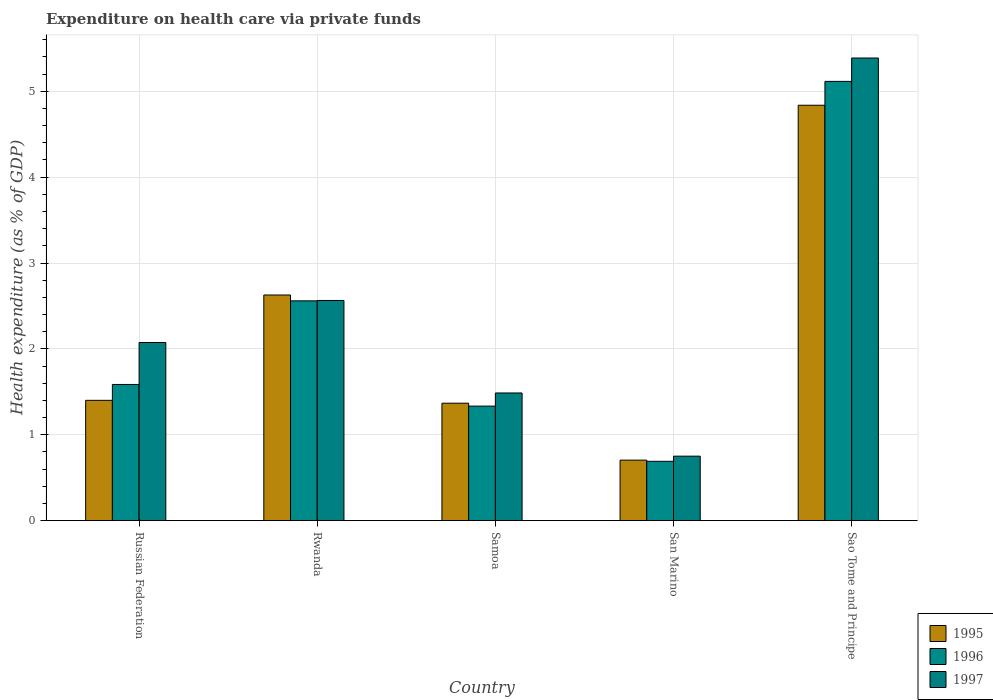How many bars are there on the 5th tick from the left?
Give a very brief answer. 3. What is the label of the 2nd group of bars from the left?
Offer a very short reply. Rwanda. In how many cases, is the number of bars for a given country not equal to the number of legend labels?
Your answer should be compact. 0. What is the expenditure made on health care in 1997 in Russian Federation?
Give a very brief answer. 2.07. Across all countries, what is the maximum expenditure made on health care in 1997?
Make the answer very short. 5.39. Across all countries, what is the minimum expenditure made on health care in 1996?
Offer a very short reply. 0.69. In which country was the expenditure made on health care in 1996 maximum?
Ensure brevity in your answer.  Sao Tome and Principe. In which country was the expenditure made on health care in 1996 minimum?
Ensure brevity in your answer.  San Marino. What is the total expenditure made on health care in 1995 in the graph?
Your response must be concise. 10.94. What is the difference between the expenditure made on health care in 1997 in Rwanda and that in San Marino?
Ensure brevity in your answer.  1.81. What is the difference between the expenditure made on health care in 1997 in Samoa and the expenditure made on health care in 1996 in San Marino?
Give a very brief answer. 0.8. What is the average expenditure made on health care in 1996 per country?
Your answer should be very brief. 2.26. What is the difference between the expenditure made on health care of/in 1995 and expenditure made on health care of/in 1996 in San Marino?
Ensure brevity in your answer.  0.01. In how many countries, is the expenditure made on health care in 1996 greater than 3 %?
Make the answer very short. 1. What is the ratio of the expenditure made on health care in 1996 in Rwanda to that in Samoa?
Provide a short and direct response. 1.92. Is the difference between the expenditure made on health care in 1995 in Russian Federation and Rwanda greater than the difference between the expenditure made on health care in 1996 in Russian Federation and Rwanda?
Offer a terse response. No. What is the difference between the highest and the second highest expenditure made on health care in 1997?
Give a very brief answer. 0.49. What is the difference between the highest and the lowest expenditure made on health care in 1997?
Provide a succinct answer. 4.64. In how many countries, is the expenditure made on health care in 1997 greater than the average expenditure made on health care in 1997 taken over all countries?
Make the answer very short. 2. Is the sum of the expenditure made on health care in 1995 in Rwanda and Sao Tome and Principe greater than the maximum expenditure made on health care in 1996 across all countries?
Keep it short and to the point. Yes. What does the 1st bar from the left in San Marino represents?
Provide a short and direct response. 1995. What does the 1st bar from the right in Sao Tome and Principe represents?
Offer a terse response. 1997. Is it the case that in every country, the sum of the expenditure made on health care in 1995 and expenditure made on health care in 1996 is greater than the expenditure made on health care in 1997?
Your response must be concise. Yes. What is the difference between two consecutive major ticks on the Y-axis?
Make the answer very short. 1. Are the values on the major ticks of Y-axis written in scientific E-notation?
Your answer should be compact. No. Does the graph contain grids?
Provide a short and direct response. Yes. How are the legend labels stacked?
Your response must be concise. Vertical. What is the title of the graph?
Offer a terse response. Expenditure on health care via private funds. What is the label or title of the Y-axis?
Make the answer very short. Health expenditure (as % of GDP). What is the Health expenditure (as % of GDP) in 1995 in Russian Federation?
Provide a succinct answer. 1.4. What is the Health expenditure (as % of GDP) in 1996 in Russian Federation?
Provide a short and direct response. 1.59. What is the Health expenditure (as % of GDP) of 1997 in Russian Federation?
Give a very brief answer. 2.07. What is the Health expenditure (as % of GDP) of 1995 in Rwanda?
Give a very brief answer. 2.63. What is the Health expenditure (as % of GDP) of 1996 in Rwanda?
Keep it short and to the point. 2.56. What is the Health expenditure (as % of GDP) of 1997 in Rwanda?
Keep it short and to the point. 2.56. What is the Health expenditure (as % of GDP) in 1995 in Samoa?
Offer a very short reply. 1.37. What is the Health expenditure (as % of GDP) in 1996 in Samoa?
Your answer should be compact. 1.33. What is the Health expenditure (as % of GDP) of 1997 in Samoa?
Provide a short and direct response. 1.49. What is the Health expenditure (as % of GDP) of 1995 in San Marino?
Give a very brief answer. 0.7. What is the Health expenditure (as % of GDP) of 1996 in San Marino?
Your answer should be compact. 0.69. What is the Health expenditure (as % of GDP) in 1997 in San Marino?
Offer a terse response. 0.75. What is the Health expenditure (as % of GDP) of 1995 in Sao Tome and Principe?
Your response must be concise. 4.84. What is the Health expenditure (as % of GDP) in 1996 in Sao Tome and Principe?
Make the answer very short. 5.12. What is the Health expenditure (as % of GDP) of 1997 in Sao Tome and Principe?
Ensure brevity in your answer.  5.39. Across all countries, what is the maximum Health expenditure (as % of GDP) in 1995?
Provide a short and direct response. 4.84. Across all countries, what is the maximum Health expenditure (as % of GDP) of 1996?
Offer a very short reply. 5.12. Across all countries, what is the maximum Health expenditure (as % of GDP) of 1997?
Your answer should be compact. 5.39. Across all countries, what is the minimum Health expenditure (as % of GDP) of 1995?
Offer a very short reply. 0.7. Across all countries, what is the minimum Health expenditure (as % of GDP) of 1996?
Make the answer very short. 0.69. Across all countries, what is the minimum Health expenditure (as % of GDP) in 1997?
Offer a terse response. 0.75. What is the total Health expenditure (as % of GDP) of 1995 in the graph?
Give a very brief answer. 10.94. What is the total Health expenditure (as % of GDP) in 1996 in the graph?
Your answer should be compact. 11.28. What is the total Health expenditure (as % of GDP) in 1997 in the graph?
Provide a succinct answer. 12.26. What is the difference between the Health expenditure (as % of GDP) of 1995 in Russian Federation and that in Rwanda?
Offer a very short reply. -1.23. What is the difference between the Health expenditure (as % of GDP) of 1996 in Russian Federation and that in Rwanda?
Keep it short and to the point. -0.97. What is the difference between the Health expenditure (as % of GDP) in 1997 in Russian Federation and that in Rwanda?
Give a very brief answer. -0.49. What is the difference between the Health expenditure (as % of GDP) of 1996 in Russian Federation and that in Samoa?
Your response must be concise. 0.25. What is the difference between the Health expenditure (as % of GDP) of 1997 in Russian Federation and that in Samoa?
Give a very brief answer. 0.59. What is the difference between the Health expenditure (as % of GDP) of 1995 in Russian Federation and that in San Marino?
Your answer should be very brief. 0.7. What is the difference between the Health expenditure (as % of GDP) in 1996 in Russian Federation and that in San Marino?
Your answer should be very brief. 0.9. What is the difference between the Health expenditure (as % of GDP) of 1997 in Russian Federation and that in San Marino?
Your response must be concise. 1.32. What is the difference between the Health expenditure (as % of GDP) in 1995 in Russian Federation and that in Sao Tome and Principe?
Give a very brief answer. -3.44. What is the difference between the Health expenditure (as % of GDP) in 1996 in Russian Federation and that in Sao Tome and Principe?
Provide a succinct answer. -3.53. What is the difference between the Health expenditure (as % of GDP) in 1997 in Russian Federation and that in Sao Tome and Principe?
Make the answer very short. -3.31. What is the difference between the Health expenditure (as % of GDP) of 1995 in Rwanda and that in Samoa?
Keep it short and to the point. 1.26. What is the difference between the Health expenditure (as % of GDP) of 1996 in Rwanda and that in Samoa?
Ensure brevity in your answer.  1.23. What is the difference between the Health expenditure (as % of GDP) of 1997 in Rwanda and that in Samoa?
Offer a very short reply. 1.08. What is the difference between the Health expenditure (as % of GDP) of 1995 in Rwanda and that in San Marino?
Keep it short and to the point. 1.92. What is the difference between the Health expenditure (as % of GDP) in 1996 in Rwanda and that in San Marino?
Provide a short and direct response. 1.87. What is the difference between the Health expenditure (as % of GDP) of 1997 in Rwanda and that in San Marino?
Your response must be concise. 1.81. What is the difference between the Health expenditure (as % of GDP) in 1995 in Rwanda and that in Sao Tome and Principe?
Your response must be concise. -2.21. What is the difference between the Health expenditure (as % of GDP) in 1996 in Rwanda and that in Sao Tome and Principe?
Ensure brevity in your answer.  -2.56. What is the difference between the Health expenditure (as % of GDP) in 1997 in Rwanda and that in Sao Tome and Principe?
Provide a short and direct response. -2.82. What is the difference between the Health expenditure (as % of GDP) in 1995 in Samoa and that in San Marino?
Ensure brevity in your answer.  0.66. What is the difference between the Health expenditure (as % of GDP) of 1996 in Samoa and that in San Marino?
Give a very brief answer. 0.64. What is the difference between the Health expenditure (as % of GDP) in 1997 in Samoa and that in San Marino?
Offer a very short reply. 0.74. What is the difference between the Health expenditure (as % of GDP) of 1995 in Samoa and that in Sao Tome and Principe?
Make the answer very short. -3.47. What is the difference between the Health expenditure (as % of GDP) of 1996 in Samoa and that in Sao Tome and Principe?
Give a very brief answer. -3.78. What is the difference between the Health expenditure (as % of GDP) in 1997 in Samoa and that in Sao Tome and Principe?
Your response must be concise. -3.9. What is the difference between the Health expenditure (as % of GDP) of 1995 in San Marino and that in Sao Tome and Principe?
Give a very brief answer. -4.13. What is the difference between the Health expenditure (as % of GDP) in 1996 in San Marino and that in Sao Tome and Principe?
Your answer should be very brief. -4.43. What is the difference between the Health expenditure (as % of GDP) of 1997 in San Marino and that in Sao Tome and Principe?
Keep it short and to the point. -4.64. What is the difference between the Health expenditure (as % of GDP) of 1995 in Russian Federation and the Health expenditure (as % of GDP) of 1996 in Rwanda?
Provide a succinct answer. -1.16. What is the difference between the Health expenditure (as % of GDP) in 1995 in Russian Federation and the Health expenditure (as % of GDP) in 1997 in Rwanda?
Provide a short and direct response. -1.16. What is the difference between the Health expenditure (as % of GDP) in 1996 in Russian Federation and the Health expenditure (as % of GDP) in 1997 in Rwanda?
Keep it short and to the point. -0.98. What is the difference between the Health expenditure (as % of GDP) in 1995 in Russian Federation and the Health expenditure (as % of GDP) in 1996 in Samoa?
Make the answer very short. 0.07. What is the difference between the Health expenditure (as % of GDP) in 1995 in Russian Federation and the Health expenditure (as % of GDP) in 1997 in Samoa?
Ensure brevity in your answer.  -0.09. What is the difference between the Health expenditure (as % of GDP) of 1996 in Russian Federation and the Health expenditure (as % of GDP) of 1997 in Samoa?
Make the answer very short. 0.1. What is the difference between the Health expenditure (as % of GDP) of 1995 in Russian Federation and the Health expenditure (as % of GDP) of 1996 in San Marino?
Your answer should be compact. 0.71. What is the difference between the Health expenditure (as % of GDP) in 1995 in Russian Federation and the Health expenditure (as % of GDP) in 1997 in San Marino?
Make the answer very short. 0.65. What is the difference between the Health expenditure (as % of GDP) of 1996 in Russian Federation and the Health expenditure (as % of GDP) of 1997 in San Marino?
Your response must be concise. 0.84. What is the difference between the Health expenditure (as % of GDP) of 1995 in Russian Federation and the Health expenditure (as % of GDP) of 1996 in Sao Tome and Principe?
Give a very brief answer. -3.72. What is the difference between the Health expenditure (as % of GDP) of 1995 in Russian Federation and the Health expenditure (as % of GDP) of 1997 in Sao Tome and Principe?
Make the answer very short. -3.99. What is the difference between the Health expenditure (as % of GDP) in 1996 in Russian Federation and the Health expenditure (as % of GDP) in 1997 in Sao Tome and Principe?
Provide a succinct answer. -3.8. What is the difference between the Health expenditure (as % of GDP) of 1995 in Rwanda and the Health expenditure (as % of GDP) of 1996 in Samoa?
Keep it short and to the point. 1.29. What is the difference between the Health expenditure (as % of GDP) in 1995 in Rwanda and the Health expenditure (as % of GDP) in 1997 in Samoa?
Your answer should be compact. 1.14. What is the difference between the Health expenditure (as % of GDP) of 1996 in Rwanda and the Health expenditure (as % of GDP) of 1997 in Samoa?
Your response must be concise. 1.07. What is the difference between the Health expenditure (as % of GDP) in 1995 in Rwanda and the Health expenditure (as % of GDP) in 1996 in San Marino?
Your answer should be very brief. 1.94. What is the difference between the Health expenditure (as % of GDP) of 1995 in Rwanda and the Health expenditure (as % of GDP) of 1997 in San Marino?
Your answer should be compact. 1.88. What is the difference between the Health expenditure (as % of GDP) of 1996 in Rwanda and the Health expenditure (as % of GDP) of 1997 in San Marino?
Offer a terse response. 1.81. What is the difference between the Health expenditure (as % of GDP) of 1995 in Rwanda and the Health expenditure (as % of GDP) of 1996 in Sao Tome and Principe?
Provide a succinct answer. -2.49. What is the difference between the Health expenditure (as % of GDP) of 1995 in Rwanda and the Health expenditure (as % of GDP) of 1997 in Sao Tome and Principe?
Make the answer very short. -2.76. What is the difference between the Health expenditure (as % of GDP) in 1996 in Rwanda and the Health expenditure (as % of GDP) in 1997 in Sao Tome and Principe?
Make the answer very short. -2.83. What is the difference between the Health expenditure (as % of GDP) of 1995 in Samoa and the Health expenditure (as % of GDP) of 1996 in San Marino?
Give a very brief answer. 0.68. What is the difference between the Health expenditure (as % of GDP) in 1995 in Samoa and the Health expenditure (as % of GDP) in 1997 in San Marino?
Offer a very short reply. 0.62. What is the difference between the Health expenditure (as % of GDP) in 1996 in Samoa and the Health expenditure (as % of GDP) in 1997 in San Marino?
Your answer should be compact. 0.58. What is the difference between the Health expenditure (as % of GDP) in 1995 in Samoa and the Health expenditure (as % of GDP) in 1996 in Sao Tome and Principe?
Your answer should be compact. -3.75. What is the difference between the Health expenditure (as % of GDP) in 1995 in Samoa and the Health expenditure (as % of GDP) in 1997 in Sao Tome and Principe?
Offer a terse response. -4.02. What is the difference between the Health expenditure (as % of GDP) in 1996 in Samoa and the Health expenditure (as % of GDP) in 1997 in Sao Tome and Principe?
Offer a very short reply. -4.05. What is the difference between the Health expenditure (as % of GDP) in 1995 in San Marino and the Health expenditure (as % of GDP) in 1996 in Sao Tome and Principe?
Your answer should be compact. -4.41. What is the difference between the Health expenditure (as % of GDP) of 1995 in San Marino and the Health expenditure (as % of GDP) of 1997 in Sao Tome and Principe?
Give a very brief answer. -4.68. What is the difference between the Health expenditure (as % of GDP) of 1996 in San Marino and the Health expenditure (as % of GDP) of 1997 in Sao Tome and Principe?
Your response must be concise. -4.7. What is the average Health expenditure (as % of GDP) in 1995 per country?
Make the answer very short. 2.19. What is the average Health expenditure (as % of GDP) in 1996 per country?
Your answer should be compact. 2.26. What is the average Health expenditure (as % of GDP) of 1997 per country?
Your answer should be very brief. 2.45. What is the difference between the Health expenditure (as % of GDP) in 1995 and Health expenditure (as % of GDP) in 1996 in Russian Federation?
Keep it short and to the point. -0.18. What is the difference between the Health expenditure (as % of GDP) in 1995 and Health expenditure (as % of GDP) in 1997 in Russian Federation?
Give a very brief answer. -0.67. What is the difference between the Health expenditure (as % of GDP) of 1996 and Health expenditure (as % of GDP) of 1997 in Russian Federation?
Provide a succinct answer. -0.49. What is the difference between the Health expenditure (as % of GDP) of 1995 and Health expenditure (as % of GDP) of 1996 in Rwanda?
Keep it short and to the point. 0.07. What is the difference between the Health expenditure (as % of GDP) in 1995 and Health expenditure (as % of GDP) in 1997 in Rwanda?
Make the answer very short. 0.06. What is the difference between the Health expenditure (as % of GDP) of 1996 and Health expenditure (as % of GDP) of 1997 in Rwanda?
Your answer should be compact. -0. What is the difference between the Health expenditure (as % of GDP) in 1995 and Health expenditure (as % of GDP) in 1996 in Samoa?
Your answer should be very brief. 0.03. What is the difference between the Health expenditure (as % of GDP) of 1995 and Health expenditure (as % of GDP) of 1997 in Samoa?
Give a very brief answer. -0.12. What is the difference between the Health expenditure (as % of GDP) in 1996 and Health expenditure (as % of GDP) in 1997 in Samoa?
Your answer should be compact. -0.15. What is the difference between the Health expenditure (as % of GDP) of 1995 and Health expenditure (as % of GDP) of 1996 in San Marino?
Your answer should be compact. 0.01. What is the difference between the Health expenditure (as % of GDP) of 1995 and Health expenditure (as % of GDP) of 1997 in San Marino?
Make the answer very short. -0.05. What is the difference between the Health expenditure (as % of GDP) of 1996 and Health expenditure (as % of GDP) of 1997 in San Marino?
Offer a terse response. -0.06. What is the difference between the Health expenditure (as % of GDP) of 1995 and Health expenditure (as % of GDP) of 1996 in Sao Tome and Principe?
Your response must be concise. -0.28. What is the difference between the Health expenditure (as % of GDP) in 1995 and Health expenditure (as % of GDP) in 1997 in Sao Tome and Principe?
Your response must be concise. -0.55. What is the difference between the Health expenditure (as % of GDP) of 1996 and Health expenditure (as % of GDP) of 1997 in Sao Tome and Principe?
Your answer should be very brief. -0.27. What is the ratio of the Health expenditure (as % of GDP) in 1995 in Russian Federation to that in Rwanda?
Ensure brevity in your answer.  0.53. What is the ratio of the Health expenditure (as % of GDP) in 1996 in Russian Federation to that in Rwanda?
Provide a short and direct response. 0.62. What is the ratio of the Health expenditure (as % of GDP) in 1997 in Russian Federation to that in Rwanda?
Give a very brief answer. 0.81. What is the ratio of the Health expenditure (as % of GDP) in 1995 in Russian Federation to that in Samoa?
Your response must be concise. 1.02. What is the ratio of the Health expenditure (as % of GDP) of 1996 in Russian Federation to that in Samoa?
Your answer should be compact. 1.19. What is the ratio of the Health expenditure (as % of GDP) of 1997 in Russian Federation to that in Samoa?
Make the answer very short. 1.4. What is the ratio of the Health expenditure (as % of GDP) in 1995 in Russian Federation to that in San Marino?
Keep it short and to the point. 1.99. What is the ratio of the Health expenditure (as % of GDP) in 1996 in Russian Federation to that in San Marino?
Provide a short and direct response. 2.3. What is the ratio of the Health expenditure (as % of GDP) of 1997 in Russian Federation to that in San Marino?
Your answer should be compact. 2.76. What is the ratio of the Health expenditure (as % of GDP) in 1995 in Russian Federation to that in Sao Tome and Principe?
Give a very brief answer. 0.29. What is the ratio of the Health expenditure (as % of GDP) in 1996 in Russian Federation to that in Sao Tome and Principe?
Offer a terse response. 0.31. What is the ratio of the Health expenditure (as % of GDP) of 1997 in Russian Federation to that in Sao Tome and Principe?
Offer a very short reply. 0.38. What is the ratio of the Health expenditure (as % of GDP) in 1995 in Rwanda to that in Samoa?
Ensure brevity in your answer.  1.92. What is the ratio of the Health expenditure (as % of GDP) of 1996 in Rwanda to that in Samoa?
Make the answer very short. 1.92. What is the ratio of the Health expenditure (as % of GDP) in 1997 in Rwanda to that in Samoa?
Make the answer very short. 1.72. What is the ratio of the Health expenditure (as % of GDP) of 1995 in Rwanda to that in San Marino?
Offer a terse response. 3.73. What is the ratio of the Health expenditure (as % of GDP) in 1996 in Rwanda to that in San Marino?
Your answer should be compact. 3.71. What is the ratio of the Health expenditure (as % of GDP) in 1997 in Rwanda to that in San Marino?
Make the answer very short. 3.42. What is the ratio of the Health expenditure (as % of GDP) of 1995 in Rwanda to that in Sao Tome and Principe?
Provide a short and direct response. 0.54. What is the ratio of the Health expenditure (as % of GDP) in 1996 in Rwanda to that in Sao Tome and Principe?
Keep it short and to the point. 0.5. What is the ratio of the Health expenditure (as % of GDP) of 1997 in Rwanda to that in Sao Tome and Principe?
Provide a succinct answer. 0.48. What is the ratio of the Health expenditure (as % of GDP) of 1995 in Samoa to that in San Marino?
Your response must be concise. 1.94. What is the ratio of the Health expenditure (as % of GDP) of 1996 in Samoa to that in San Marino?
Ensure brevity in your answer.  1.93. What is the ratio of the Health expenditure (as % of GDP) in 1997 in Samoa to that in San Marino?
Your answer should be very brief. 1.98. What is the ratio of the Health expenditure (as % of GDP) of 1995 in Samoa to that in Sao Tome and Principe?
Your response must be concise. 0.28. What is the ratio of the Health expenditure (as % of GDP) of 1996 in Samoa to that in Sao Tome and Principe?
Offer a terse response. 0.26. What is the ratio of the Health expenditure (as % of GDP) in 1997 in Samoa to that in Sao Tome and Principe?
Your answer should be very brief. 0.28. What is the ratio of the Health expenditure (as % of GDP) in 1995 in San Marino to that in Sao Tome and Principe?
Keep it short and to the point. 0.15. What is the ratio of the Health expenditure (as % of GDP) of 1996 in San Marino to that in Sao Tome and Principe?
Provide a succinct answer. 0.13. What is the ratio of the Health expenditure (as % of GDP) in 1997 in San Marino to that in Sao Tome and Principe?
Keep it short and to the point. 0.14. What is the difference between the highest and the second highest Health expenditure (as % of GDP) in 1995?
Give a very brief answer. 2.21. What is the difference between the highest and the second highest Health expenditure (as % of GDP) of 1996?
Make the answer very short. 2.56. What is the difference between the highest and the second highest Health expenditure (as % of GDP) of 1997?
Your answer should be very brief. 2.82. What is the difference between the highest and the lowest Health expenditure (as % of GDP) of 1995?
Offer a very short reply. 4.13. What is the difference between the highest and the lowest Health expenditure (as % of GDP) of 1996?
Provide a short and direct response. 4.43. What is the difference between the highest and the lowest Health expenditure (as % of GDP) in 1997?
Your answer should be very brief. 4.64. 